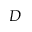Convert formula to latex. <formula><loc_0><loc_0><loc_500><loc_500>D</formula> 